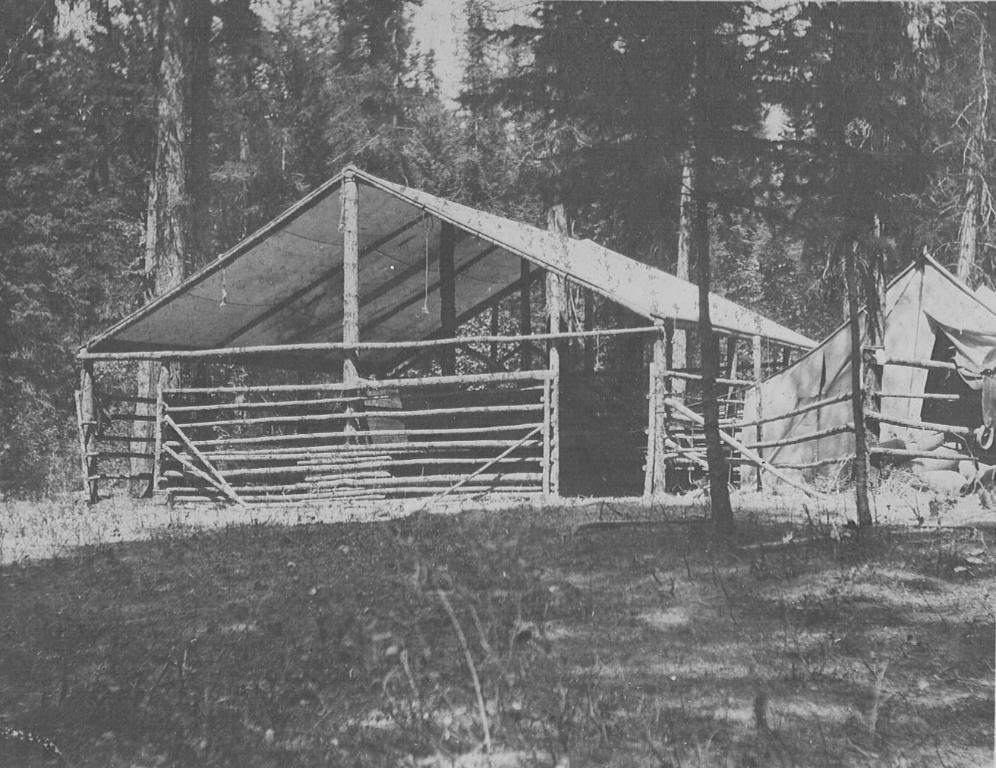What is the color scheme of the image? The image is black and white. What type of location is depicted in the image? There is a cattle farm in the image. What type of shelter is visible in the image? There is a tent in the image. What type of vegetation is present in the image? There are tall trees in the image. What type of ground cover is present in the image? There is grass in the image. Where is the baby playing with a patch in the image? There is no baby or patch present in the image. What type of current is flowing through the image? There is no current present in the image; it is a black and white photograph. 